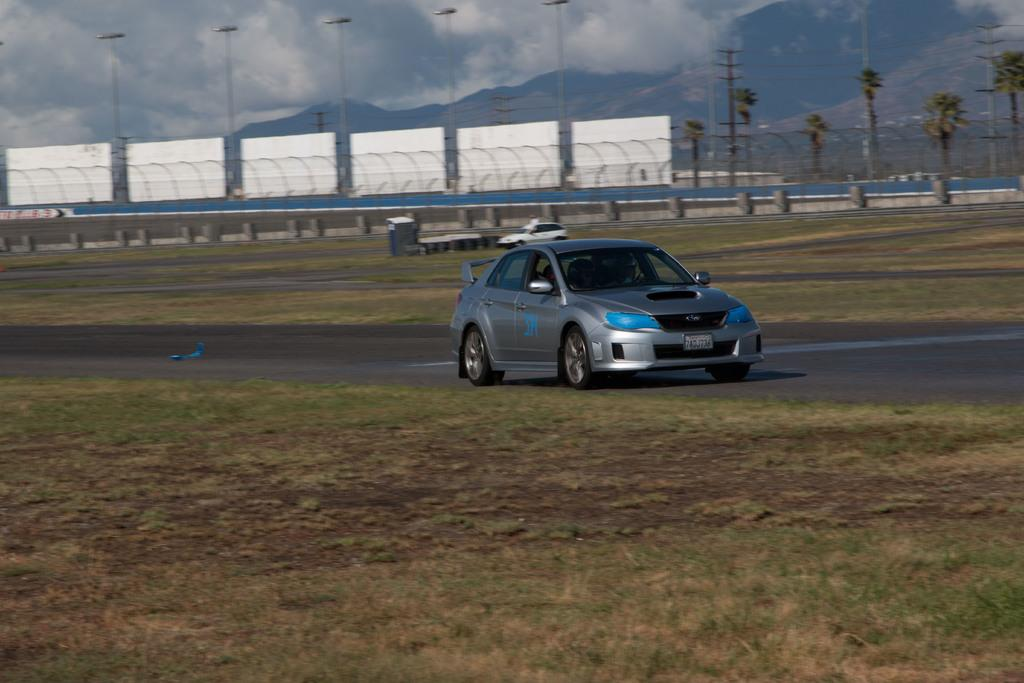What can be seen on the road in the image? There are vehicles on the road in the image. What type of barrier is visible in the image? There is fencing visible in the image. What type of natural elements are present in the image? Trees are present in the image. What type of infrastructure can be seen in the image? Current poles are visible in the image. What type of utility is present in the image? Wires are present in the image. What type of signage is present in the image? White color boards are in the image. What is visible in the background of the image? The sky is visible in the image and has a white and blue color. Is there any quicksand visible in the image? No, there is no quicksand present in the image. What type of story is being told in the image? The image does not depict a story; it is a photograph of a scene with vehicles, fencing, trees, current poles, wires, white color boards, and the sky. Where is the playground located in the image? There is no playground present in the image. 